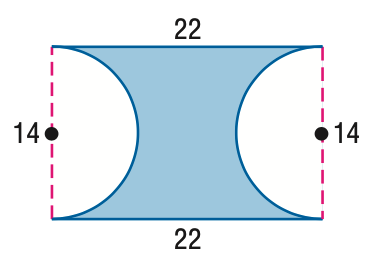Answer the mathemtical geometry problem and directly provide the correct option letter.
Question: Find the area of the figure. Round to the nearest tenth if necessary.
Choices: A: 154.1 B: 231.0 C: 307.6 D: 308 A 